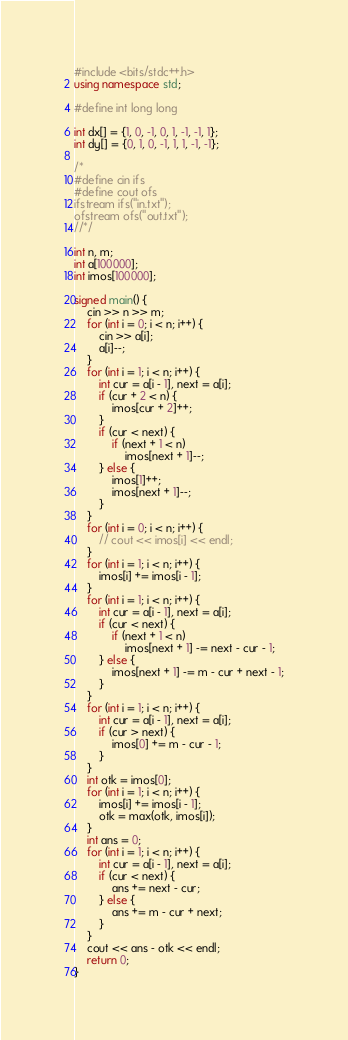<code> <loc_0><loc_0><loc_500><loc_500><_C++_>#include <bits/stdc++.h>
using namespace std;

#define int long long

int dx[] = {1, 0, -1, 0, 1, -1, -1, 1};
int dy[] = {0, 1, 0, -1, 1, 1, -1, -1};

/*
#define cin ifs
#define cout ofs
ifstream ifs("in.txt");
ofstream ofs("out.txt");
//*/

int n, m;
int a[100000];
int imos[100000];

signed main() {
    cin >> n >> m;
    for (int i = 0; i < n; i++) {
        cin >> a[i];
        a[i]--;
    }
    for (int i = 1; i < n; i++) {
        int cur = a[i - 1], next = a[i];
        if (cur + 2 < n) {
            imos[cur + 2]++;
        }
        if (cur < next) {
            if (next + 1 < n)
                imos[next + 1]--;
        } else {
            imos[1]++;
            imos[next + 1]--;
        }
    }
    for (int i = 0; i < n; i++) {
        // cout << imos[i] << endl;
    }
    for (int i = 1; i < n; i++) {
        imos[i] += imos[i - 1];
    }
    for (int i = 1; i < n; i++) {
        int cur = a[i - 1], next = a[i];
        if (cur < next) {
            if (next + 1 < n)
                imos[next + 1] -= next - cur - 1;
        } else {
            imos[next + 1] -= m - cur + next - 1;
        }
    }
    for (int i = 1; i < n; i++) {
        int cur = a[i - 1], next = a[i];
        if (cur > next) {
            imos[0] += m - cur - 1;
        }
    }
    int otk = imos[0];
    for (int i = 1; i < n; i++) {
        imos[i] += imos[i - 1];
        otk = max(otk, imos[i]);
    }
    int ans = 0;
    for (int i = 1; i < n; i++) {
        int cur = a[i - 1], next = a[i];
        if (cur < next) {
            ans += next - cur;
        } else {
            ans += m - cur + next;
        }
    }
    cout << ans - otk << endl;
    return 0;
}</code> 